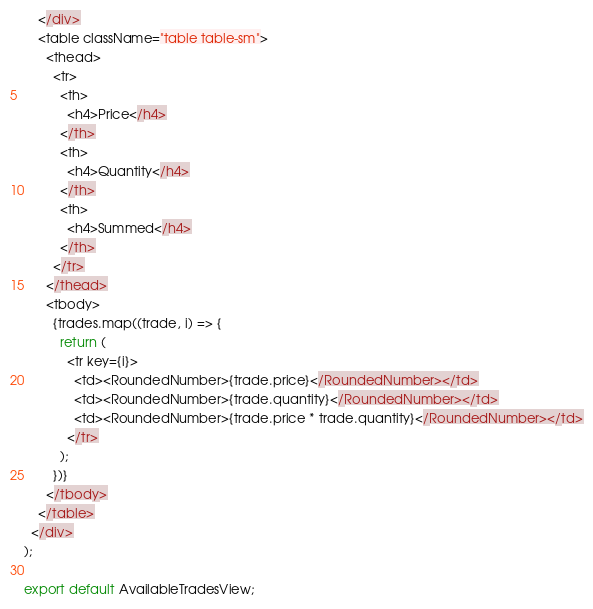<code> <loc_0><loc_0><loc_500><loc_500><_JavaScript_>    </div>
    <table className="table table-sm">
      <thead>
        <tr>
          <th>
            <h4>Price</h4>
          </th>
          <th>
            <h4>Quantity</h4>
          </th>
          <th>
            <h4>Summed</h4>
          </th>
        </tr>
      </thead>
      <tbody>
        {trades.map((trade, i) => {
          return (
            <tr key={i}>
              <td><RoundedNumber>{trade.price}</RoundedNumber></td>
              <td><RoundedNumber>{trade.quantity}</RoundedNumber></td>
              <td><RoundedNumber>{trade.price * trade.quantity}</RoundedNumber></td>
            </tr>
          );
        })}
      </tbody>
    </table>
  </div>
);

export default AvailableTradesView;
</code> 